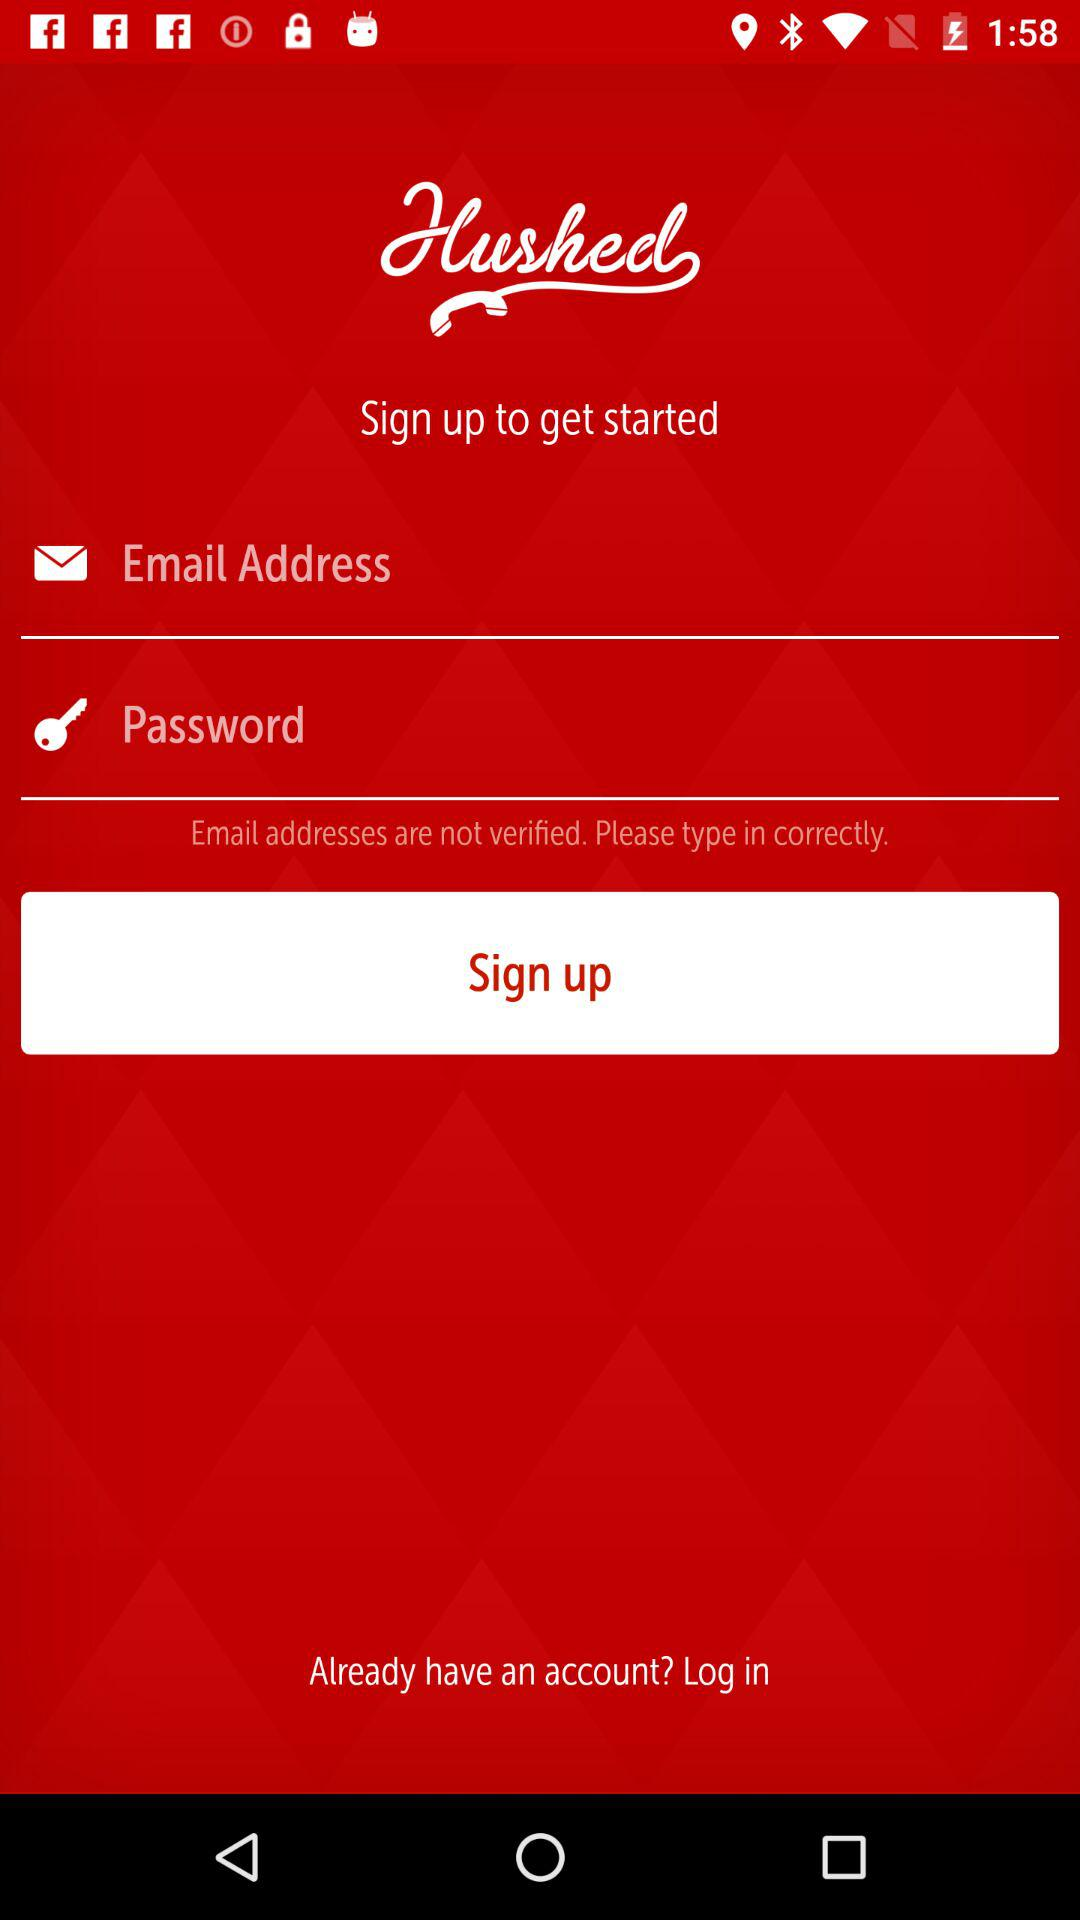What are the requirements to sign up? The requirements to sign up are "Email Address" and "Password". 